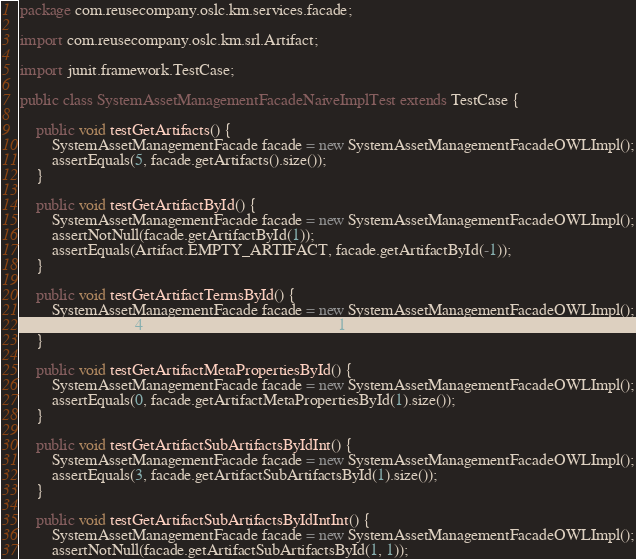Convert code to text. <code><loc_0><loc_0><loc_500><loc_500><_Java_>package com.reusecompany.oslc.km.services.facade;

import com.reusecompany.oslc.km.srl.Artifact;

import junit.framework.TestCase;

public class SystemAssetManagementFacadeNaiveImplTest extends TestCase {

	public void testGetArtifacts() {
		SystemAssetManagementFacade facade = new SystemAssetManagementFacadeOWLImpl();
		assertEquals(5, facade.getArtifacts().size());
	}

	public void testGetArtifactById() {
		SystemAssetManagementFacade facade = new SystemAssetManagementFacadeOWLImpl();
		assertNotNull(facade.getArtifactById(1));
		assertEquals(Artifact.EMPTY_ARTIFACT, facade.getArtifactById(-1));
	}

	public void testGetArtifactTermsById() {
		SystemAssetManagementFacade facade = new SystemAssetManagementFacadeOWLImpl();
		assertEquals(4, facade.getArtifactTermsById(1).size());
	}

	public void testGetArtifactMetaPropertiesById() {
		SystemAssetManagementFacade facade = new SystemAssetManagementFacadeOWLImpl();
		assertEquals(0, facade.getArtifactMetaPropertiesById(1).size());
	}

	public void testGetArtifactSubArtifactsByIdInt() {
		SystemAssetManagementFacade facade = new SystemAssetManagementFacadeOWLImpl();
		assertEquals(3, facade.getArtifactSubArtifactsById(1).size());
	}

	public void testGetArtifactSubArtifactsByIdIntInt() {
		SystemAssetManagementFacade facade = new SystemAssetManagementFacadeOWLImpl();
		assertNotNull(facade.getArtifactSubArtifactsById(1, 1));</code> 